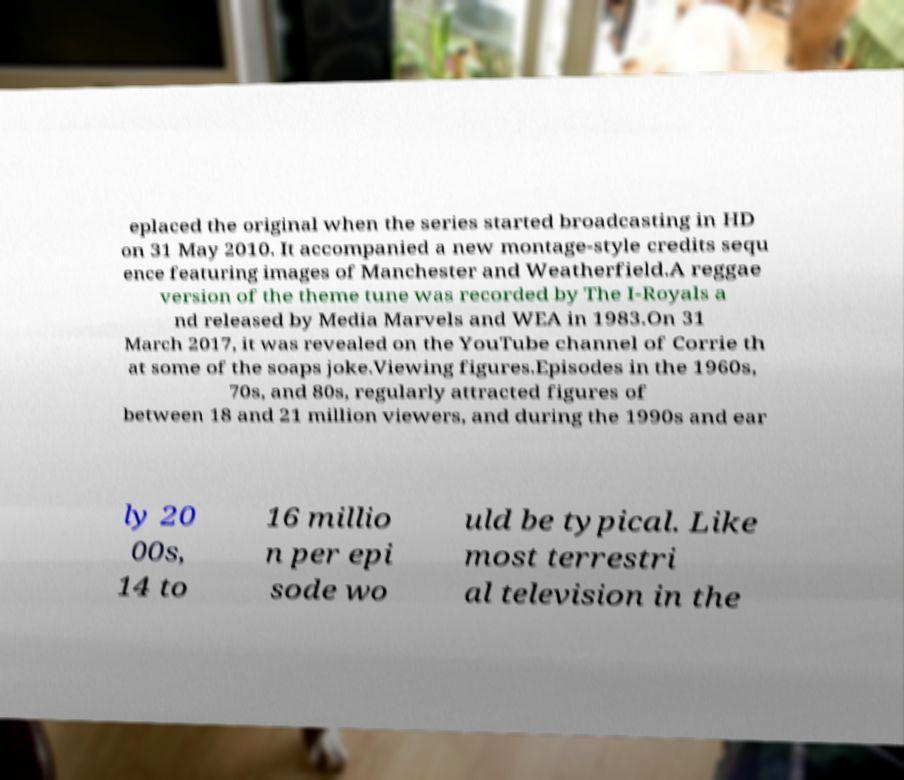I need the written content from this picture converted into text. Can you do that? eplaced the original when the series started broadcasting in HD on 31 May 2010. It accompanied a new montage-style credits sequ ence featuring images of Manchester and Weatherfield.A reggae version of the theme tune was recorded by The I-Royals a nd released by Media Marvels and WEA in 1983.On 31 March 2017, it was revealed on the YouTube channel of Corrie th at some of the soaps joke.Viewing figures.Episodes in the 1960s, 70s, and 80s, regularly attracted figures of between 18 and 21 million viewers, and during the 1990s and ear ly 20 00s, 14 to 16 millio n per epi sode wo uld be typical. Like most terrestri al television in the 